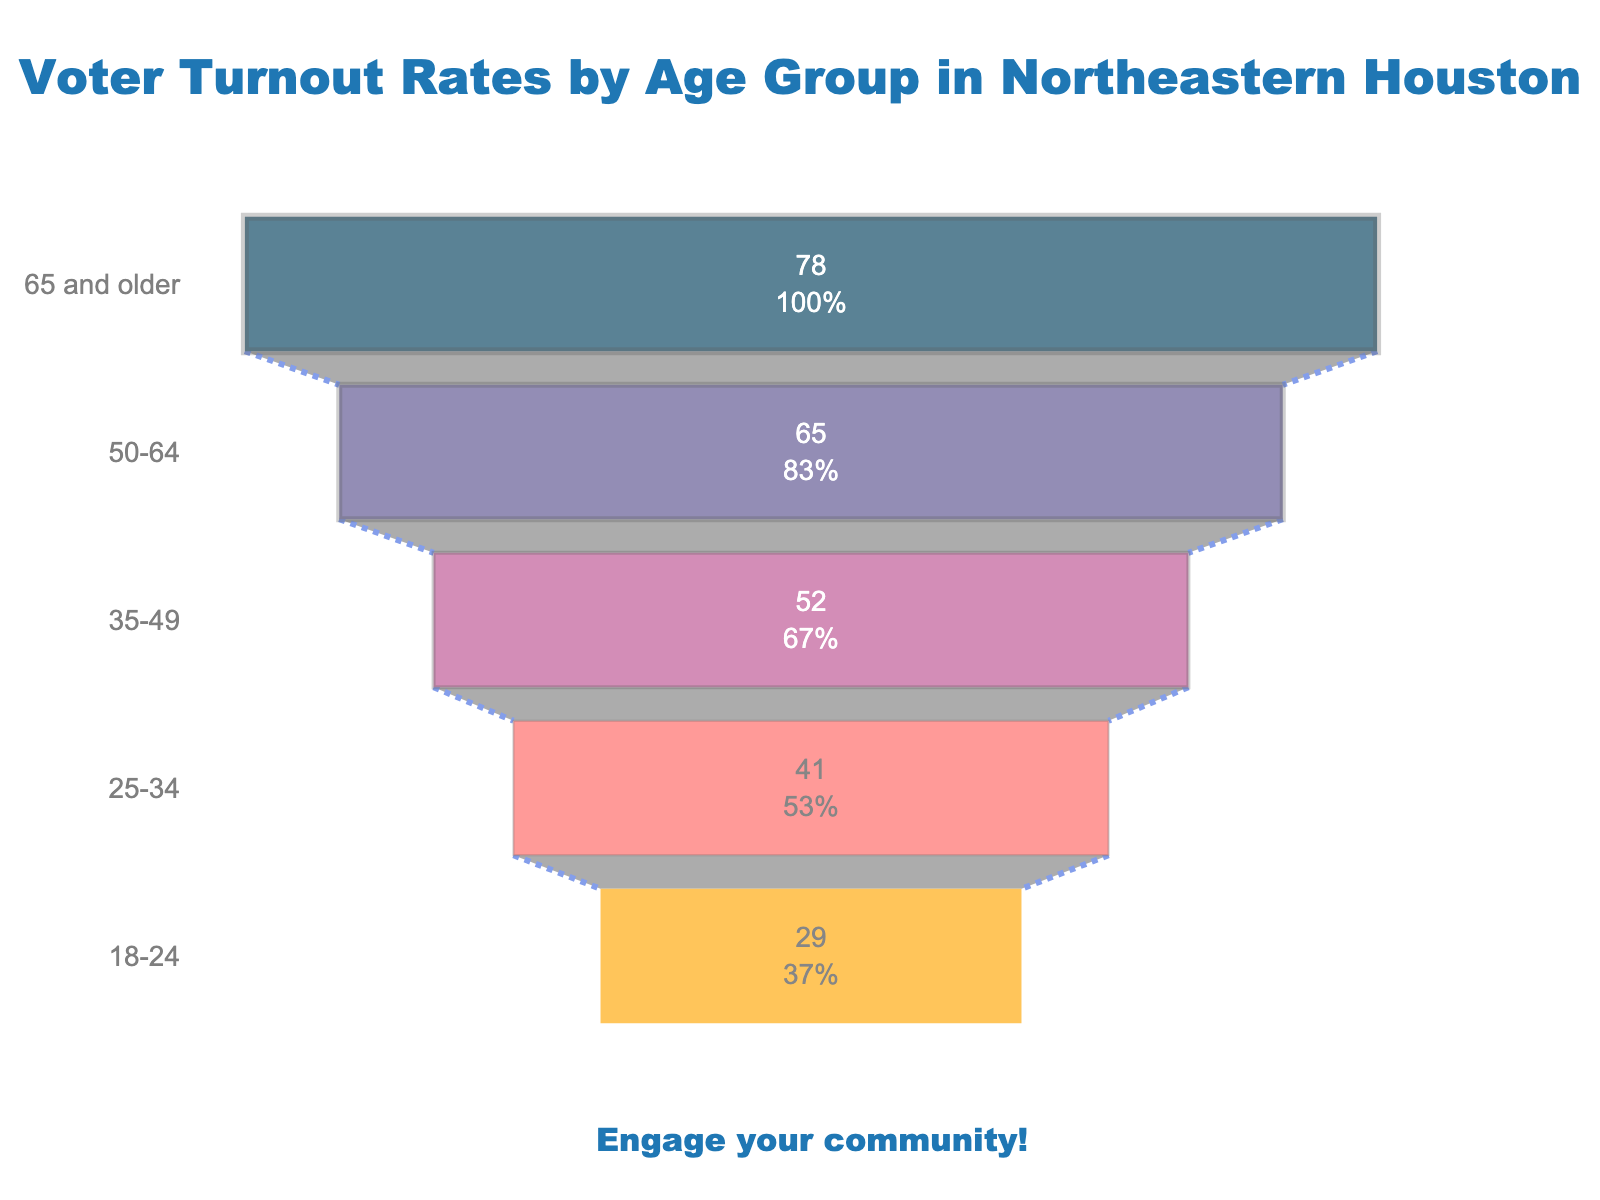What is the highest voter turnout rate according to the figure? The age group "65 and older" has the highest voter turnout rate. It shows a percentage of 78% in the funnel chart.
Answer: 78% How many age groups are displayed in the figure? By counting each age group listed on the y-axis of the funnel chart, we see that there are five age groups shown.
Answer: 5 Which age group has the lowest voter turnout rate? The age group "18-24" has the lowest voter turnout rate, which is 29%.
Answer: 18-24 What is the difference in the voter turnout rate between the "50-64" age group and the "18-24" age group? The "50-64" age group has a turnout rate of 65%, while the "18-24" age group stands at 29%. The difference is 65% - 29% = 36%.
Answer: 36% What percentage of the initial value does the voter turnout rate of the "25-34" age group represent in the funnel chart? The "25-34" age group has a 41% turnout rate. As an initial value, 41% shows the exact value among the total number of voters.
Answer: 41% Which age group has a voter turnout rate almost exactly halfway between the highest and lowest turnout rates? The highest rate is 78% for "65 and older," and the lowest is 29% for "18-24". Halfway is (78% + 29%) / 2 = 53.5%. The "35-49" age group has a turnout rate of 52%, close to the midpoint.
Answer: 35-49 How much lower is the voter turnout rate of the "35-49" age group compared to the "65 and older" age group? The "65 and older" age group has a turnout rate of 78%, while the "35-49" age group is at 52%. The difference is 78% - 52% = 26%.
Answer: 26% What is the average voter turnout rate across all age groups shown in the figure? To find the average, sum the voter turnout rates (78% + 65% + 52% + 41% + 29%) = 265%, then divide by the number of age groups (5). So, 265% / 5 = 53%.
Answer: 53% How does the opacity and color transition in the funnel chart contribute to the visual representation? The opacity set to 0.65 and the color varying from dark to light through age groups help to visually emphasize the decrease in voter turnout rates across the age groups. This gradient makes it clear which groups have higher and lower rates.
Answer: Emphasize rate decrease How does the voter turnout rate for "25-34" compare to the average turnout rate across all the age groups? The "25-34" age group has a voter turnout rate of 41%. The average turnout rate across all age groups is 53%. Thus, the "25-34" rate is 53% - 41% = 12% below the average.
Answer: 12% below average 